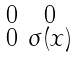Convert formula to latex. <formula><loc_0><loc_0><loc_500><loc_500>\begin{smallmatrix} 0 & 0 \\ 0 & \sigma ( x ) \end{smallmatrix}</formula> 